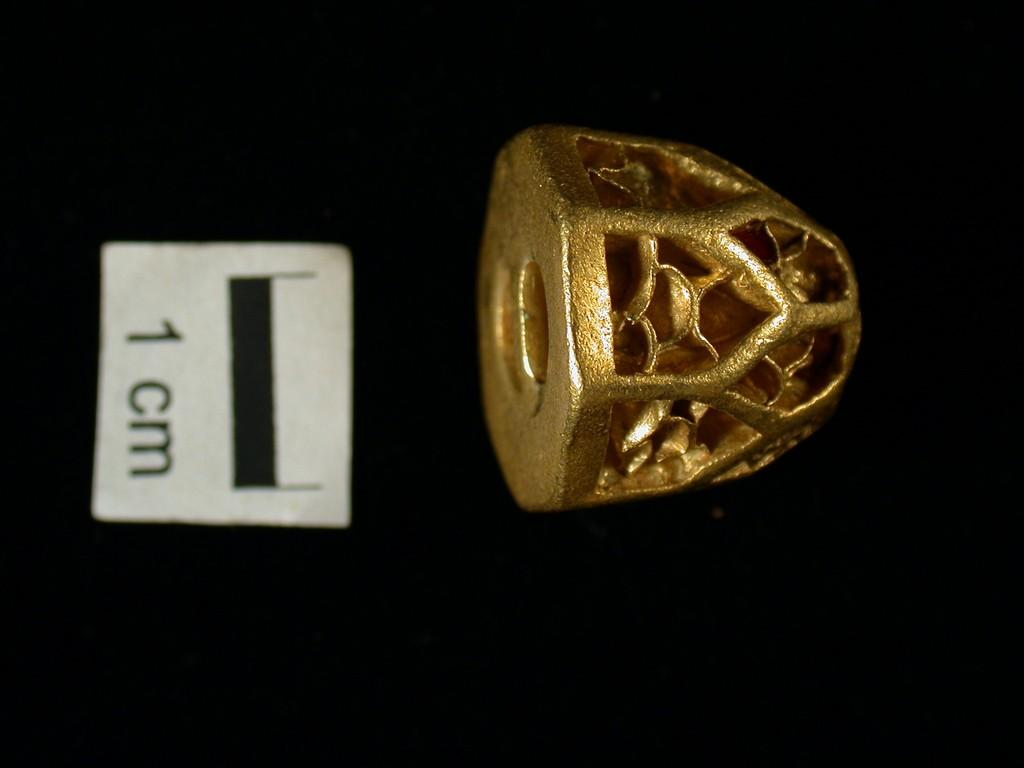What can be seen in the picture? There is an ornament in the picture. Where is the paper with text located in the picture? The paper with text is on the left side of the picture. What color is the cloth at the bottom of the picture? The cloth at the bottom of the picture is black. What type of plastic material is used to make the quill in the image? There is no quill present in the image, so it is not possible to determine the type of plastic material used. 